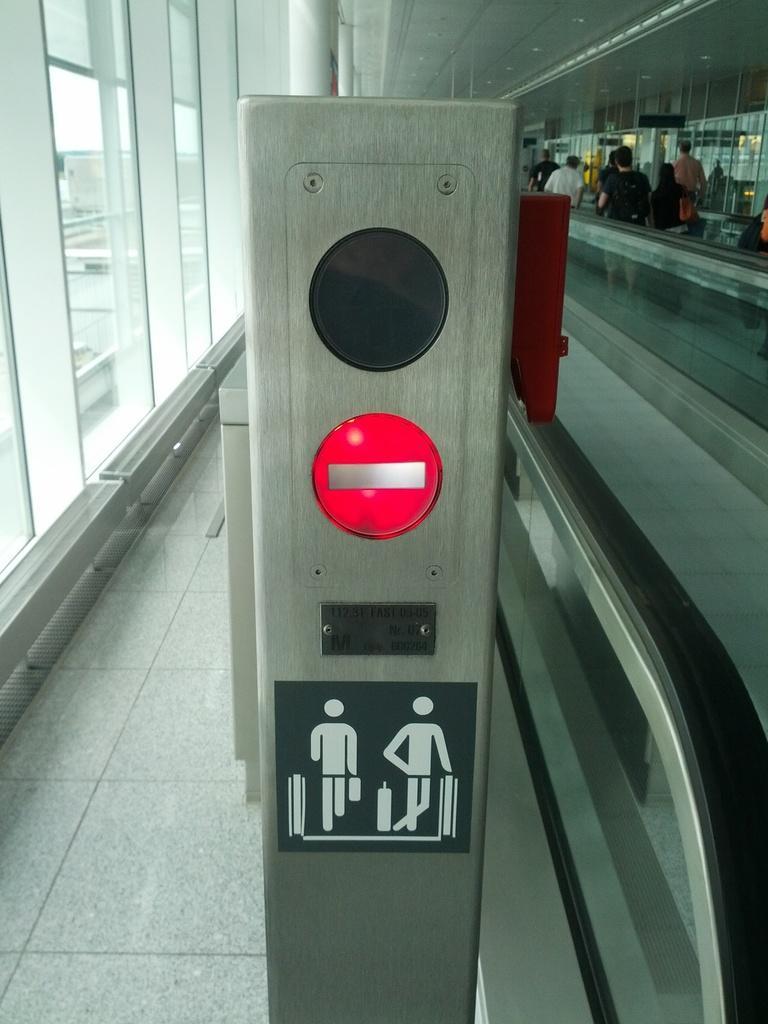How would you summarize this image in a sentence or two? In this image, this looks like a machine with the signboard. I think this is an escalator. I can see few people standing. These are the glass doors. I think this picture was taken inside the building. 